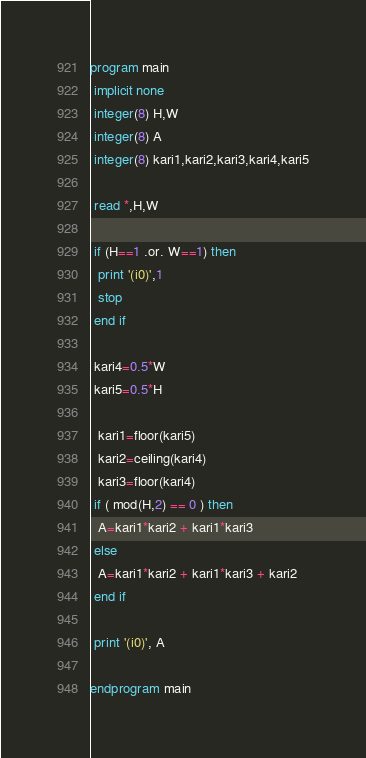<code> <loc_0><loc_0><loc_500><loc_500><_FORTRAN_>program main
 implicit none
 integer(8) H,W
 integer(8) A
 integer(8) kari1,kari2,kari3,kari4,kari5

 read *,H,W

 if (H==1 .or. W==1) then
  print '(i0)',1
  stop
 end if

 kari4=0.5*W
 kari5=0.5*H

  kari1=floor(kari5)
  kari2=ceiling(kari4)
  kari3=floor(kari4)
 if ( mod(H,2) == 0 ) then
  A=kari1*kari2 + kari1*kari3
 else
  A=kari1*kari2 + kari1*kari3 + kari2
 end if

 print '(i0)', A

endprogram main
</code> 